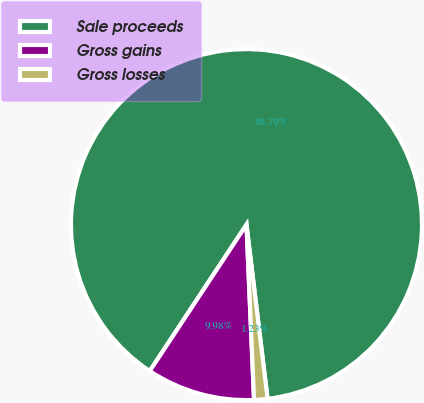Convert chart. <chart><loc_0><loc_0><loc_500><loc_500><pie_chart><fcel>Sale proceeds<fcel>Gross gains<fcel>Gross losses<nl><fcel>88.79%<fcel>9.98%<fcel>1.23%<nl></chart> 